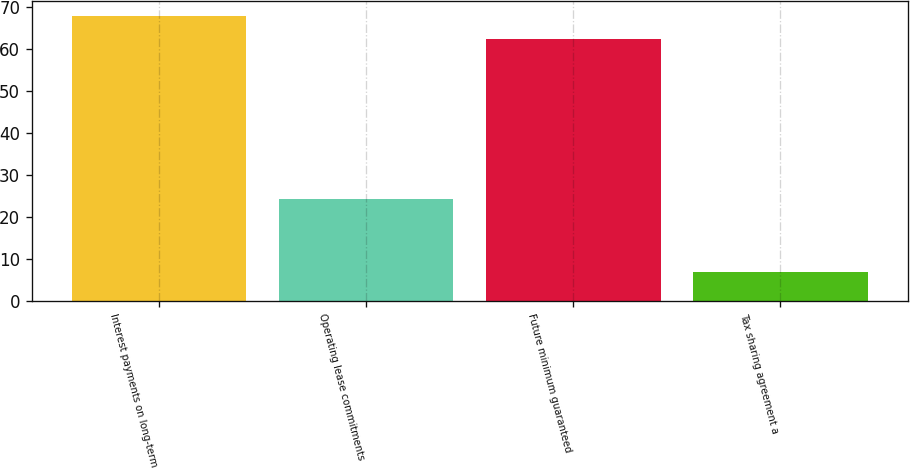<chart> <loc_0><loc_0><loc_500><loc_500><bar_chart><fcel>Interest payments on long-term<fcel>Operating lease commitments<fcel>Future minimum guaranteed<fcel>Tax sharing agreement a<nl><fcel>67.98<fcel>24.3<fcel>62.3<fcel>7<nl></chart> 